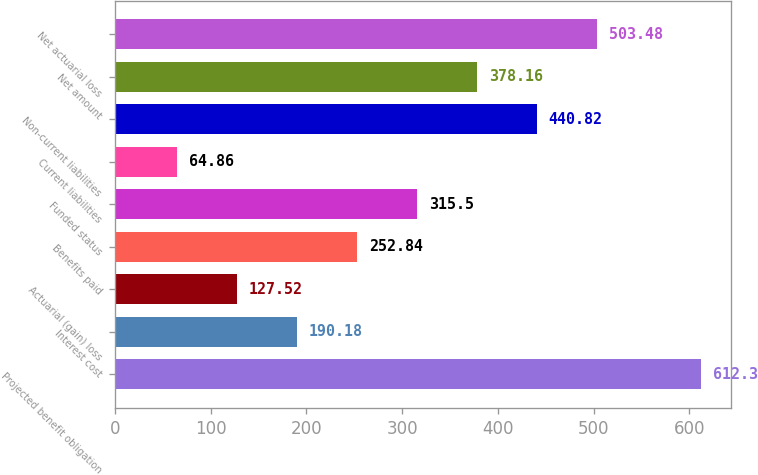Convert chart to OTSL. <chart><loc_0><loc_0><loc_500><loc_500><bar_chart><fcel>Projected benefit obligation<fcel>Interest cost<fcel>Actuarial (gain) loss<fcel>Benefits paid<fcel>Funded status<fcel>Current liabilities<fcel>Non-current liabilities<fcel>Net amount<fcel>Net actuarial loss<nl><fcel>612.3<fcel>190.18<fcel>127.52<fcel>252.84<fcel>315.5<fcel>64.86<fcel>440.82<fcel>378.16<fcel>503.48<nl></chart> 